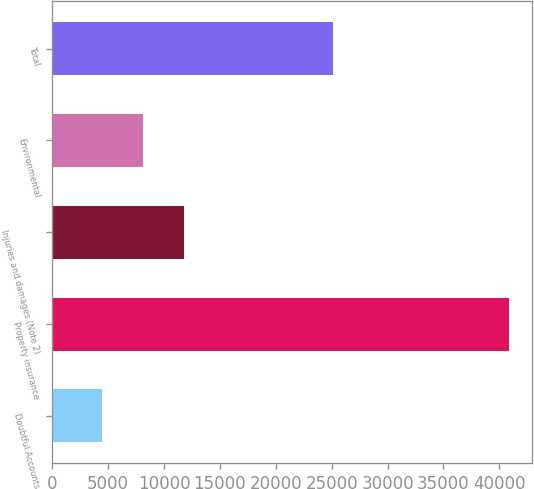<chart> <loc_0><loc_0><loc_500><loc_500><bar_chart><fcel>Doubtful Accounts<fcel>Property insurance<fcel>Injuries and damages (Note 2)<fcel>Environmental<fcel>Total<nl><fcel>4487<fcel>40878<fcel>11765.2<fcel>8126.1<fcel>25096<nl></chart> 